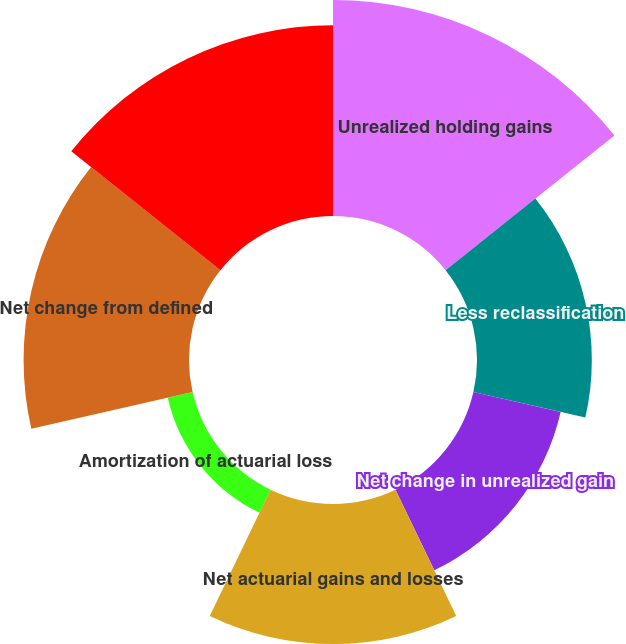Convert chart. <chart><loc_0><loc_0><loc_500><loc_500><pie_chart><fcel>Unrealized holding gains<fcel>Less reclassification<fcel>Net change in unrealized gain<fcel>Net actuarial gains and losses<fcel>Amortization of actuarial loss<fcel>Net change from defined<fcel>Other comprehensive income<nl><fcel>22.93%<fcel>12.19%<fcel>9.5%<fcel>14.87%<fcel>2.71%<fcel>17.56%<fcel>20.25%<nl></chart> 